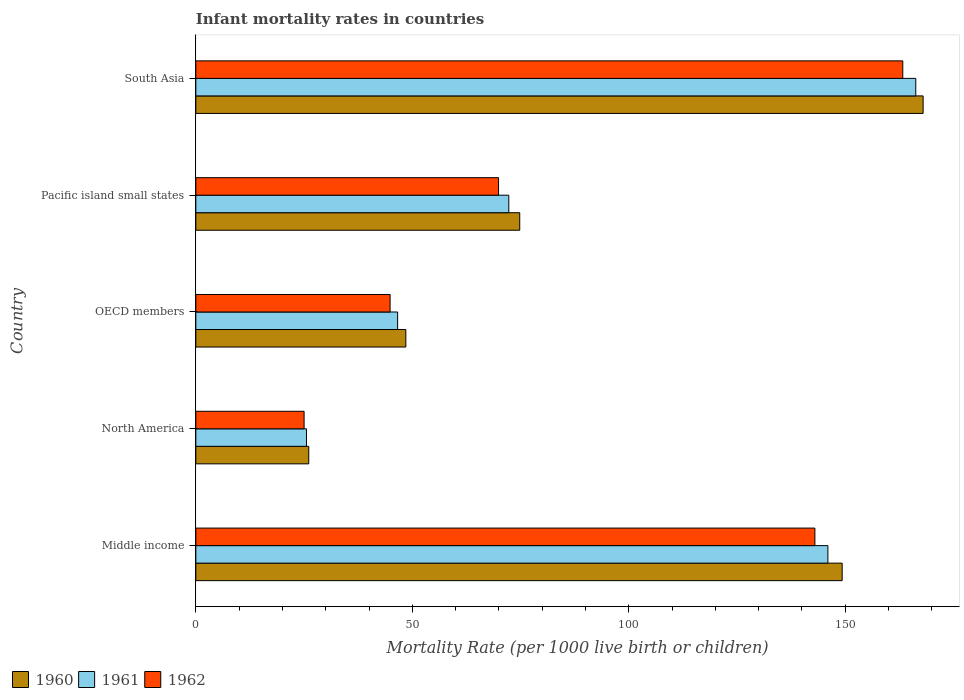How many groups of bars are there?
Your answer should be very brief. 5. What is the label of the 4th group of bars from the top?
Keep it short and to the point. North America. What is the infant mortality rate in 1961 in North America?
Your answer should be compact. 25.56. Across all countries, what is the maximum infant mortality rate in 1961?
Your answer should be very brief. 166.3. Across all countries, what is the minimum infant mortality rate in 1960?
Offer a very short reply. 26.08. In which country was the infant mortality rate in 1961 minimum?
Ensure brevity in your answer.  North America. What is the total infant mortality rate in 1960 in the graph?
Give a very brief answer. 466.71. What is the difference between the infant mortality rate in 1961 in Pacific island small states and that in South Asia?
Give a very brief answer. -94.01. What is the difference between the infant mortality rate in 1960 in South Asia and the infant mortality rate in 1961 in OECD members?
Your answer should be very brief. 121.39. What is the average infant mortality rate in 1962 per country?
Provide a short and direct response. 89.22. What is the difference between the infant mortality rate in 1962 and infant mortality rate in 1961 in South Asia?
Make the answer very short. -3. What is the ratio of the infant mortality rate in 1960 in OECD members to that in South Asia?
Your answer should be very brief. 0.29. What is the difference between the highest and the second highest infant mortality rate in 1962?
Offer a terse response. 20.3. What is the difference between the highest and the lowest infant mortality rate in 1960?
Make the answer very short. 141.92. In how many countries, is the infant mortality rate in 1961 greater than the average infant mortality rate in 1961 taken over all countries?
Provide a short and direct response. 2. Is the sum of the infant mortality rate in 1961 in North America and OECD members greater than the maximum infant mortality rate in 1962 across all countries?
Ensure brevity in your answer.  No. What does the 1st bar from the bottom in Middle income represents?
Offer a very short reply. 1960. Is it the case that in every country, the sum of the infant mortality rate in 1962 and infant mortality rate in 1961 is greater than the infant mortality rate in 1960?
Ensure brevity in your answer.  Yes. How many bars are there?
Ensure brevity in your answer.  15. Does the graph contain grids?
Ensure brevity in your answer.  No. Where does the legend appear in the graph?
Your answer should be very brief. Bottom left. How many legend labels are there?
Your answer should be very brief. 3. How are the legend labels stacked?
Your answer should be very brief. Horizontal. What is the title of the graph?
Your answer should be very brief. Infant mortality rates in countries. Does "1980" appear as one of the legend labels in the graph?
Offer a terse response. No. What is the label or title of the X-axis?
Make the answer very short. Mortality Rate (per 1000 live birth or children). What is the label or title of the Y-axis?
Keep it short and to the point. Country. What is the Mortality Rate (per 1000 live birth or children) of 1960 in Middle income?
Offer a terse response. 149.3. What is the Mortality Rate (per 1000 live birth or children) of 1961 in Middle income?
Your answer should be very brief. 146. What is the Mortality Rate (per 1000 live birth or children) of 1962 in Middle income?
Give a very brief answer. 143. What is the Mortality Rate (per 1000 live birth or children) in 1960 in North America?
Your response must be concise. 26.08. What is the Mortality Rate (per 1000 live birth or children) in 1961 in North America?
Your answer should be very brief. 25.56. What is the Mortality Rate (per 1000 live birth or children) of 1962 in North America?
Offer a terse response. 25.01. What is the Mortality Rate (per 1000 live birth or children) in 1960 in OECD members?
Make the answer very short. 48.51. What is the Mortality Rate (per 1000 live birth or children) of 1961 in OECD members?
Keep it short and to the point. 46.61. What is the Mortality Rate (per 1000 live birth or children) in 1962 in OECD members?
Give a very brief answer. 44.87. What is the Mortality Rate (per 1000 live birth or children) in 1960 in Pacific island small states?
Your answer should be very brief. 74.82. What is the Mortality Rate (per 1000 live birth or children) of 1961 in Pacific island small states?
Offer a terse response. 72.29. What is the Mortality Rate (per 1000 live birth or children) of 1962 in Pacific island small states?
Give a very brief answer. 69.93. What is the Mortality Rate (per 1000 live birth or children) of 1960 in South Asia?
Provide a succinct answer. 168. What is the Mortality Rate (per 1000 live birth or children) of 1961 in South Asia?
Offer a terse response. 166.3. What is the Mortality Rate (per 1000 live birth or children) in 1962 in South Asia?
Your answer should be very brief. 163.3. Across all countries, what is the maximum Mortality Rate (per 1000 live birth or children) of 1960?
Your response must be concise. 168. Across all countries, what is the maximum Mortality Rate (per 1000 live birth or children) of 1961?
Offer a terse response. 166.3. Across all countries, what is the maximum Mortality Rate (per 1000 live birth or children) in 1962?
Your response must be concise. 163.3. Across all countries, what is the minimum Mortality Rate (per 1000 live birth or children) of 1960?
Your response must be concise. 26.08. Across all countries, what is the minimum Mortality Rate (per 1000 live birth or children) of 1961?
Your answer should be compact. 25.56. Across all countries, what is the minimum Mortality Rate (per 1000 live birth or children) of 1962?
Your answer should be very brief. 25.01. What is the total Mortality Rate (per 1000 live birth or children) in 1960 in the graph?
Ensure brevity in your answer.  466.71. What is the total Mortality Rate (per 1000 live birth or children) of 1961 in the graph?
Offer a very short reply. 456.76. What is the total Mortality Rate (per 1000 live birth or children) in 1962 in the graph?
Offer a terse response. 446.1. What is the difference between the Mortality Rate (per 1000 live birth or children) in 1960 in Middle income and that in North America?
Your response must be concise. 123.22. What is the difference between the Mortality Rate (per 1000 live birth or children) in 1961 in Middle income and that in North America?
Provide a succinct answer. 120.44. What is the difference between the Mortality Rate (per 1000 live birth or children) in 1962 in Middle income and that in North America?
Offer a terse response. 117.99. What is the difference between the Mortality Rate (per 1000 live birth or children) of 1960 in Middle income and that in OECD members?
Your response must be concise. 100.79. What is the difference between the Mortality Rate (per 1000 live birth or children) of 1961 in Middle income and that in OECD members?
Your answer should be very brief. 99.39. What is the difference between the Mortality Rate (per 1000 live birth or children) of 1962 in Middle income and that in OECD members?
Offer a very short reply. 98.13. What is the difference between the Mortality Rate (per 1000 live birth or children) of 1960 in Middle income and that in Pacific island small states?
Provide a succinct answer. 74.48. What is the difference between the Mortality Rate (per 1000 live birth or children) in 1961 in Middle income and that in Pacific island small states?
Give a very brief answer. 73.71. What is the difference between the Mortality Rate (per 1000 live birth or children) in 1962 in Middle income and that in Pacific island small states?
Ensure brevity in your answer.  73.07. What is the difference between the Mortality Rate (per 1000 live birth or children) in 1960 in Middle income and that in South Asia?
Ensure brevity in your answer.  -18.7. What is the difference between the Mortality Rate (per 1000 live birth or children) in 1961 in Middle income and that in South Asia?
Your answer should be very brief. -20.3. What is the difference between the Mortality Rate (per 1000 live birth or children) in 1962 in Middle income and that in South Asia?
Offer a very short reply. -20.3. What is the difference between the Mortality Rate (per 1000 live birth or children) in 1960 in North America and that in OECD members?
Your answer should be very brief. -22.42. What is the difference between the Mortality Rate (per 1000 live birth or children) in 1961 in North America and that in OECD members?
Your answer should be very brief. -21.06. What is the difference between the Mortality Rate (per 1000 live birth or children) in 1962 in North America and that in OECD members?
Your answer should be compact. -19.86. What is the difference between the Mortality Rate (per 1000 live birth or children) in 1960 in North America and that in Pacific island small states?
Your answer should be compact. -48.73. What is the difference between the Mortality Rate (per 1000 live birth or children) in 1961 in North America and that in Pacific island small states?
Your response must be concise. -46.74. What is the difference between the Mortality Rate (per 1000 live birth or children) in 1962 in North America and that in Pacific island small states?
Offer a very short reply. -44.92. What is the difference between the Mortality Rate (per 1000 live birth or children) of 1960 in North America and that in South Asia?
Offer a very short reply. -141.92. What is the difference between the Mortality Rate (per 1000 live birth or children) of 1961 in North America and that in South Asia?
Give a very brief answer. -140.74. What is the difference between the Mortality Rate (per 1000 live birth or children) of 1962 in North America and that in South Asia?
Offer a very short reply. -138.29. What is the difference between the Mortality Rate (per 1000 live birth or children) in 1960 in OECD members and that in Pacific island small states?
Your response must be concise. -26.31. What is the difference between the Mortality Rate (per 1000 live birth or children) of 1961 in OECD members and that in Pacific island small states?
Your answer should be compact. -25.68. What is the difference between the Mortality Rate (per 1000 live birth or children) in 1962 in OECD members and that in Pacific island small states?
Your answer should be compact. -25.05. What is the difference between the Mortality Rate (per 1000 live birth or children) in 1960 in OECD members and that in South Asia?
Provide a succinct answer. -119.49. What is the difference between the Mortality Rate (per 1000 live birth or children) of 1961 in OECD members and that in South Asia?
Provide a succinct answer. -119.69. What is the difference between the Mortality Rate (per 1000 live birth or children) of 1962 in OECD members and that in South Asia?
Give a very brief answer. -118.43. What is the difference between the Mortality Rate (per 1000 live birth or children) in 1960 in Pacific island small states and that in South Asia?
Provide a succinct answer. -93.18. What is the difference between the Mortality Rate (per 1000 live birth or children) in 1961 in Pacific island small states and that in South Asia?
Make the answer very short. -94.01. What is the difference between the Mortality Rate (per 1000 live birth or children) in 1962 in Pacific island small states and that in South Asia?
Give a very brief answer. -93.37. What is the difference between the Mortality Rate (per 1000 live birth or children) of 1960 in Middle income and the Mortality Rate (per 1000 live birth or children) of 1961 in North America?
Make the answer very short. 123.74. What is the difference between the Mortality Rate (per 1000 live birth or children) in 1960 in Middle income and the Mortality Rate (per 1000 live birth or children) in 1962 in North America?
Ensure brevity in your answer.  124.29. What is the difference between the Mortality Rate (per 1000 live birth or children) in 1961 in Middle income and the Mortality Rate (per 1000 live birth or children) in 1962 in North America?
Give a very brief answer. 120.99. What is the difference between the Mortality Rate (per 1000 live birth or children) of 1960 in Middle income and the Mortality Rate (per 1000 live birth or children) of 1961 in OECD members?
Make the answer very short. 102.69. What is the difference between the Mortality Rate (per 1000 live birth or children) of 1960 in Middle income and the Mortality Rate (per 1000 live birth or children) of 1962 in OECD members?
Your answer should be compact. 104.43. What is the difference between the Mortality Rate (per 1000 live birth or children) of 1961 in Middle income and the Mortality Rate (per 1000 live birth or children) of 1962 in OECD members?
Make the answer very short. 101.13. What is the difference between the Mortality Rate (per 1000 live birth or children) of 1960 in Middle income and the Mortality Rate (per 1000 live birth or children) of 1961 in Pacific island small states?
Ensure brevity in your answer.  77.01. What is the difference between the Mortality Rate (per 1000 live birth or children) of 1960 in Middle income and the Mortality Rate (per 1000 live birth or children) of 1962 in Pacific island small states?
Keep it short and to the point. 79.37. What is the difference between the Mortality Rate (per 1000 live birth or children) in 1961 in Middle income and the Mortality Rate (per 1000 live birth or children) in 1962 in Pacific island small states?
Your answer should be very brief. 76.07. What is the difference between the Mortality Rate (per 1000 live birth or children) in 1960 in Middle income and the Mortality Rate (per 1000 live birth or children) in 1961 in South Asia?
Offer a very short reply. -17. What is the difference between the Mortality Rate (per 1000 live birth or children) in 1960 in Middle income and the Mortality Rate (per 1000 live birth or children) in 1962 in South Asia?
Your response must be concise. -14. What is the difference between the Mortality Rate (per 1000 live birth or children) in 1961 in Middle income and the Mortality Rate (per 1000 live birth or children) in 1962 in South Asia?
Your answer should be very brief. -17.3. What is the difference between the Mortality Rate (per 1000 live birth or children) in 1960 in North America and the Mortality Rate (per 1000 live birth or children) in 1961 in OECD members?
Ensure brevity in your answer.  -20.53. What is the difference between the Mortality Rate (per 1000 live birth or children) of 1960 in North America and the Mortality Rate (per 1000 live birth or children) of 1962 in OECD members?
Ensure brevity in your answer.  -18.79. What is the difference between the Mortality Rate (per 1000 live birth or children) of 1961 in North America and the Mortality Rate (per 1000 live birth or children) of 1962 in OECD members?
Offer a terse response. -19.32. What is the difference between the Mortality Rate (per 1000 live birth or children) of 1960 in North America and the Mortality Rate (per 1000 live birth or children) of 1961 in Pacific island small states?
Offer a terse response. -46.21. What is the difference between the Mortality Rate (per 1000 live birth or children) of 1960 in North America and the Mortality Rate (per 1000 live birth or children) of 1962 in Pacific island small states?
Your response must be concise. -43.84. What is the difference between the Mortality Rate (per 1000 live birth or children) of 1961 in North America and the Mortality Rate (per 1000 live birth or children) of 1962 in Pacific island small states?
Provide a short and direct response. -44.37. What is the difference between the Mortality Rate (per 1000 live birth or children) of 1960 in North America and the Mortality Rate (per 1000 live birth or children) of 1961 in South Asia?
Your answer should be compact. -140.22. What is the difference between the Mortality Rate (per 1000 live birth or children) in 1960 in North America and the Mortality Rate (per 1000 live birth or children) in 1962 in South Asia?
Your answer should be compact. -137.22. What is the difference between the Mortality Rate (per 1000 live birth or children) of 1961 in North America and the Mortality Rate (per 1000 live birth or children) of 1962 in South Asia?
Offer a terse response. -137.74. What is the difference between the Mortality Rate (per 1000 live birth or children) in 1960 in OECD members and the Mortality Rate (per 1000 live birth or children) in 1961 in Pacific island small states?
Ensure brevity in your answer.  -23.78. What is the difference between the Mortality Rate (per 1000 live birth or children) in 1960 in OECD members and the Mortality Rate (per 1000 live birth or children) in 1962 in Pacific island small states?
Make the answer very short. -21.42. What is the difference between the Mortality Rate (per 1000 live birth or children) of 1961 in OECD members and the Mortality Rate (per 1000 live birth or children) of 1962 in Pacific island small states?
Keep it short and to the point. -23.31. What is the difference between the Mortality Rate (per 1000 live birth or children) of 1960 in OECD members and the Mortality Rate (per 1000 live birth or children) of 1961 in South Asia?
Offer a very short reply. -117.79. What is the difference between the Mortality Rate (per 1000 live birth or children) in 1960 in OECD members and the Mortality Rate (per 1000 live birth or children) in 1962 in South Asia?
Make the answer very short. -114.79. What is the difference between the Mortality Rate (per 1000 live birth or children) of 1961 in OECD members and the Mortality Rate (per 1000 live birth or children) of 1962 in South Asia?
Make the answer very short. -116.69. What is the difference between the Mortality Rate (per 1000 live birth or children) in 1960 in Pacific island small states and the Mortality Rate (per 1000 live birth or children) in 1961 in South Asia?
Give a very brief answer. -91.48. What is the difference between the Mortality Rate (per 1000 live birth or children) of 1960 in Pacific island small states and the Mortality Rate (per 1000 live birth or children) of 1962 in South Asia?
Your answer should be very brief. -88.48. What is the difference between the Mortality Rate (per 1000 live birth or children) in 1961 in Pacific island small states and the Mortality Rate (per 1000 live birth or children) in 1962 in South Asia?
Offer a very short reply. -91.01. What is the average Mortality Rate (per 1000 live birth or children) of 1960 per country?
Make the answer very short. 93.34. What is the average Mortality Rate (per 1000 live birth or children) of 1961 per country?
Offer a terse response. 91.35. What is the average Mortality Rate (per 1000 live birth or children) in 1962 per country?
Make the answer very short. 89.22. What is the difference between the Mortality Rate (per 1000 live birth or children) of 1960 and Mortality Rate (per 1000 live birth or children) of 1961 in Middle income?
Your response must be concise. 3.3. What is the difference between the Mortality Rate (per 1000 live birth or children) of 1961 and Mortality Rate (per 1000 live birth or children) of 1962 in Middle income?
Offer a very short reply. 3. What is the difference between the Mortality Rate (per 1000 live birth or children) of 1960 and Mortality Rate (per 1000 live birth or children) of 1961 in North America?
Ensure brevity in your answer.  0.53. What is the difference between the Mortality Rate (per 1000 live birth or children) of 1960 and Mortality Rate (per 1000 live birth or children) of 1962 in North America?
Offer a terse response. 1.08. What is the difference between the Mortality Rate (per 1000 live birth or children) in 1961 and Mortality Rate (per 1000 live birth or children) in 1962 in North America?
Make the answer very short. 0.55. What is the difference between the Mortality Rate (per 1000 live birth or children) of 1960 and Mortality Rate (per 1000 live birth or children) of 1961 in OECD members?
Keep it short and to the point. 1.89. What is the difference between the Mortality Rate (per 1000 live birth or children) of 1960 and Mortality Rate (per 1000 live birth or children) of 1962 in OECD members?
Make the answer very short. 3.64. What is the difference between the Mortality Rate (per 1000 live birth or children) in 1961 and Mortality Rate (per 1000 live birth or children) in 1962 in OECD members?
Offer a very short reply. 1.74. What is the difference between the Mortality Rate (per 1000 live birth or children) in 1960 and Mortality Rate (per 1000 live birth or children) in 1961 in Pacific island small states?
Keep it short and to the point. 2.53. What is the difference between the Mortality Rate (per 1000 live birth or children) in 1960 and Mortality Rate (per 1000 live birth or children) in 1962 in Pacific island small states?
Your answer should be compact. 4.89. What is the difference between the Mortality Rate (per 1000 live birth or children) of 1961 and Mortality Rate (per 1000 live birth or children) of 1962 in Pacific island small states?
Provide a succinct answer. 2.37. What is the ratio of the Mortality Rate (per 1000 live birth or children) in 1960 in Middle income to that in North America?
Offer a very short reply. 5.72. What is the ratio of the Mortality Rate (per 1000 live birth or children) in 1961 in Middle income to that in North America?
Offer a terse response. 5.71. What is the ratio of the Mortality Rate (per 1000 live birth or children) of 1962 in Middle income to that in North America?
Your response must be concise. 5.72. What is the ratio of the Mortality Rate (per 1000 live birth or children) of 1960 in Middle income to that in OECD members?
Give a very brief answer. 3.08. What is the ratio of the Mortality Rate (per 1000 live birth or children) in 1961 in Middle income to that in OECD members?
Provide a succinct answer. 3.13. What is the ratio of the Mortality Rate (per 1000 live birth or children) in 1962 in Middle income to that in OECD members?
Provide a succinct answer. 3.19. What is the ratio of the Mortality Rate (per 1000 live birth or children) in 1960 in Middle income to that in Pacific island small states?
Offer a very short reply. 2. What is the ratio of the Mortality Rate (per 1000 live birth or children) of 1961 in Middle income to that in Pacific island small states?
Your answer should be compact. 2.02. What is the ratio of the Mortality Rate (per 1000 live birth or children) in 1962 in Middle income to that in Pacific island small states?
Ensure brevity in your answer.  2.04. What is the ratio of the Mortality Rate (per 1000 live birth or children) of 1960 in Middle income to that in South Asia?
Give a very brief answer. 0.89. What is the ratio of the Mortality Rate (per 1000 live birth or children) in 1961 in Middle income to that in South Asia?
Ensure brevity in your answer.  0.88. What is the ratio of the Mortality Rate (per 1000 live birth or children) in 1962 in Middle income to that in South Asia?
Provide a succinct answer. 0.88. What is the ratio of the Mortality Rate (per 1000 live birth or children) of 1960 in North America to that in OECD members?
Give a very brief answer. 0.54. What is the ratio of the Mortality Rate (per 1000 live birth or children) of 1961 in North America to that in OECD members?
Give a very brief answer. 0.55. What is the ratio of the Mortality Rate (per 1000 live birth or children) of 1962 in North America to that in OECD members?
Offer a very short reply. 0.56. What is the ratio of the Mortality Rate (per 1000 live birth or children) of 1960 in North America to that in Pacific island small states?
Your answer should be compact. 0.35. What is the ratio of the Mortality Rate (per 1000 live birth or children) in 1961 in North America to that in Pacific island small states?
Provide a short and direct response. 0.35. What is the ratio of the Mortality Rate (per 1000 live birth or children) of 1962 in North America to that in Pacific island small states?
Offer a very short reply. 0.36. What is the ratio of the Mortality Rate (per 1000 live birth or children) of 1960 in North America to that in South Asia?
Keep it short and to the point. 0.16. What is the ratio of the Mortality Rate (per 1000 live birth or children) of 1961 in North America to that in South Asia?
Provide a short and direct response. 0.15. What is the ratio of the Mortality Rate (per 1000 live birth or children) of 1962 in North America to that in South Asia?
Provide a short and direct response. 0.15. What is the ratio of the Mortality Rate (per 1000 live birth or children) of 1960 in OECD members to that in Pacific island small states?
Provide a short and direct response. 0.65. What is the ratio of the Mortality Rate (per 1000 live birth or children) in 1961 in OECD members to that in Pacific island small states?
Your response must be concise. 0.64. What is the ratio of the Mortality Rate (per 1000 live birth or children) of 1962 in OECD members to that in Pacific island small states?
Provide a short and direct response. 0.64. What is the ratio of the Mortality Rate (per 1000 live birth or children) in 1960 in OECD members to that in South Asia?
Provide a succinct answer. 0.29. What is the ratio of the Mortality Rate (per 1000 live birth or children) in 1961 in OECD members to that in South Asia?
Ensure brevity in your answer.  0.28. What is the ratio of the Mortality Rate (per 1000 live birth or children) in 1962 in OECD members to that in South Asia?
Offer a terse response. 0.27. What is the ratio of the Mortality Rate (per 1000 live birth or children) in 1960 in Pacific island small states to that in South Asia?
Your answer should be compact. 0.45. What is the ratio of the Mortality Rate (per 1000 live birth or children) of 1961 in Pacific island small states to that in South Asia?
Ensure brevity in your answer.  0.43. What is the ratio of the Mortality Rate (per 1000 live birth or children) in 1962 in Pacific island small states to that in South Asia?
Your answer should be compact. 0.43. What is the difference between the highest and the second highest Mortality Rate (per 1000 live birth or children) in 1961?
Make the answer very short. 20.3. What is the difference between the highest and the second highest Mortality Rate (per 1000 live birth or children) of 1962?
Ensure brevity in your answer.  20.3. What is the difference between the highest and the lowest Mortality Rate (per 1000 live birth or children) in 1960?
Offer a terse response. 141.92. What is the difference between the highest and the lowest Mortality Rate (per 1000 live birth or children) of 1961?
Your answer should be compact. 140.74. What is the difference between the highest and the lowest Mortality Rate (per 1000 live birth or children) of 1962?
Provide a succinct answer. 138.29. 